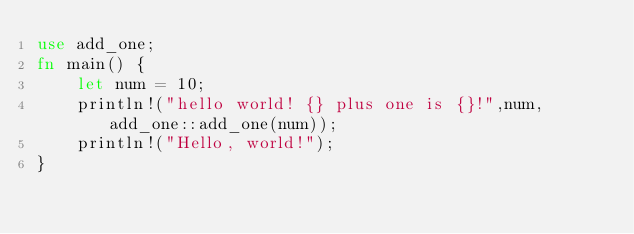Convert code to text. <code><loc_0><loc_0><loc_500><loc_500><_Rust_>use add_one;
fn main() {
    let num = 10;
    println!("hello world! {} plus one is {}!",num,add_one::add_one(num));
    println!("Hello, world!");
}
</code> 